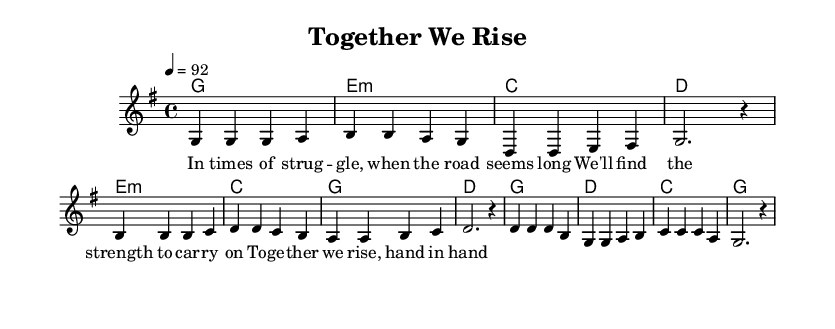What is the key signature of this music? The key signature is indicated at the beginning of the score, showing one sharp, which corresponds to the G major scale.
Answer: G major What is the time signature of this music? The time signature is represented at the start of the score, indicating that there are four beats in each measure.
Answer: 4/4 What is the tempo marking for this piece? The tempo is indicated at the beginning, showing a speed of 92 beats per minute.
Answer: 92 How many measures are in the verse section? The verse consists of four measures, which can be counted in the melody section where each group is separated by a bar line.
Answer: 4 Which chord is played during the chorus? In the chorus section, the harmonies indicate that the chord played first is G major, as the first chord of the chorus corresponds to the first melody note.
Answer: G What is the relationship between the verse and pre-chorus melodies? The pre-chorus melodies have a contrasting motif to the verse melodies, which raises the intensity as it transitions, featuring different pitches but maintaining the same rhythmic structure.
Answer: Contrast What theme do the lyrics of this piece express? The lyrics convey a message of support and unity during difficult times, emphasizing togetherness and resilience.
Answer: Unity 